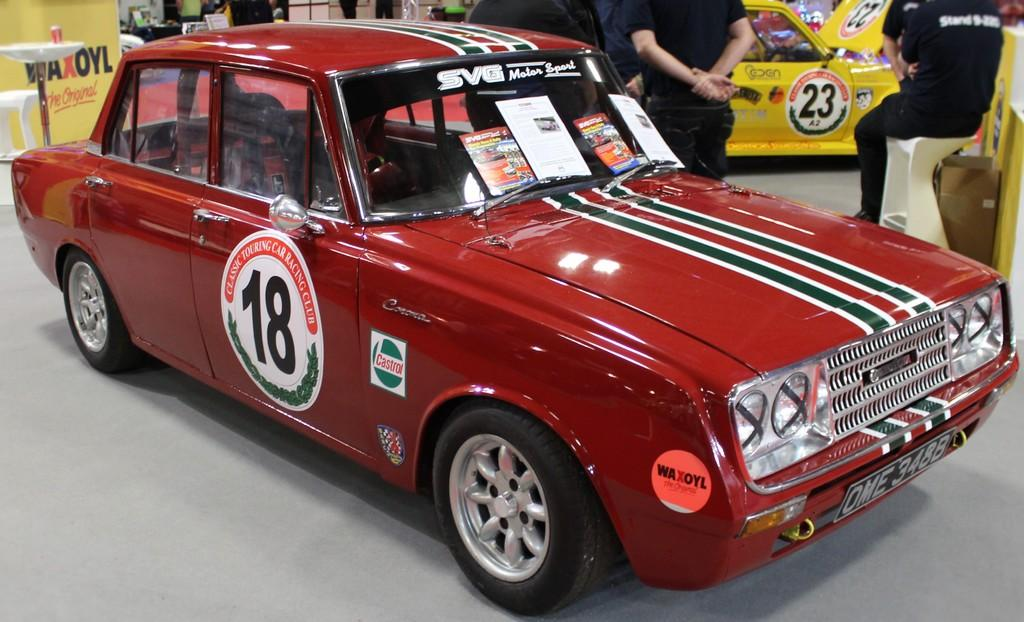What type of objects are present in the image that have headlights and number plates? There are vehicles in the image that have headlights and number plates. What is the surface on which the vehicles are located? There is a floor in the image. Are there any human beings present in the image? Yes, there are people in the image. What are the people wearing? The people are wearing clothes. How many eyes can be seen on the vehicles in the image? Vehicles do not have eyes; they have headlights. What type of letters are visible on the people's clothes in the image? There is no information about the letters on the people's clothes in the image. 